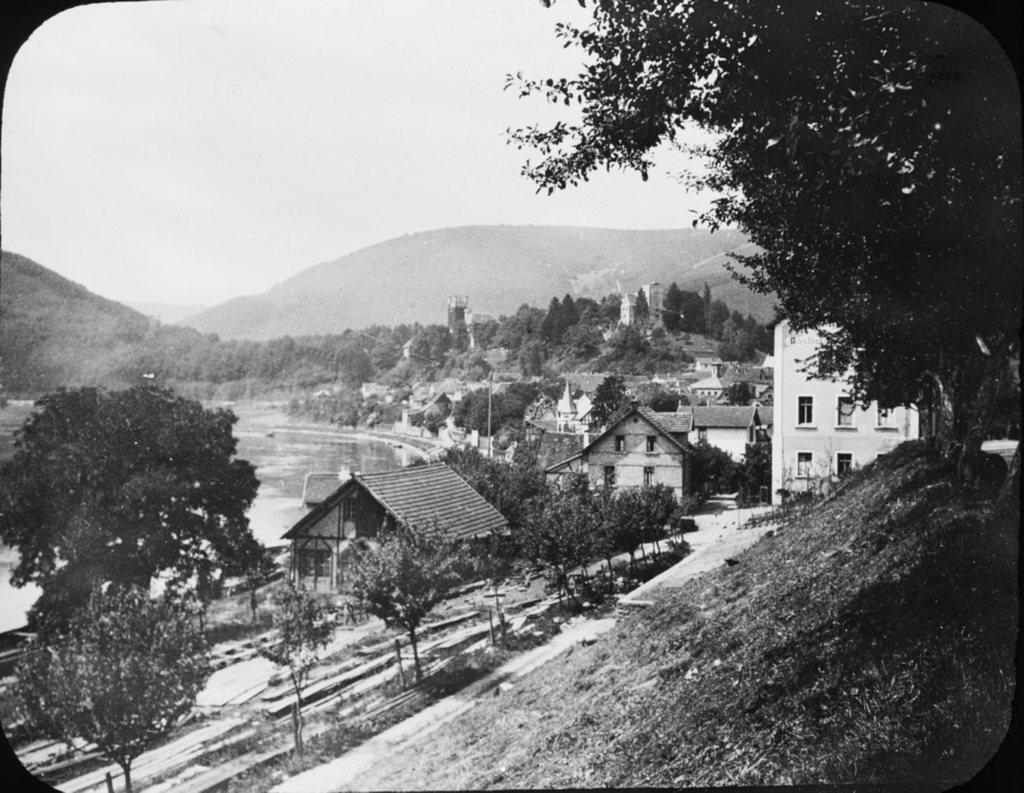What is the color scheme of the image? The image is black and white. What type of natural elements can be seen in the image? There are trees and water visible in the image. What type of man-made structures are present in the image? There are houses in the image. What is the largest geographical feature in the image? There is a mountain in the image. What is visible in the background of the image? The sky is visible in the background of the image. Can you hear the sound of thunder in the image? There is no sound present in the image, so it is not possible to hear thunder. What type of wheel is visible in the image? There is no wheel present in the image. 